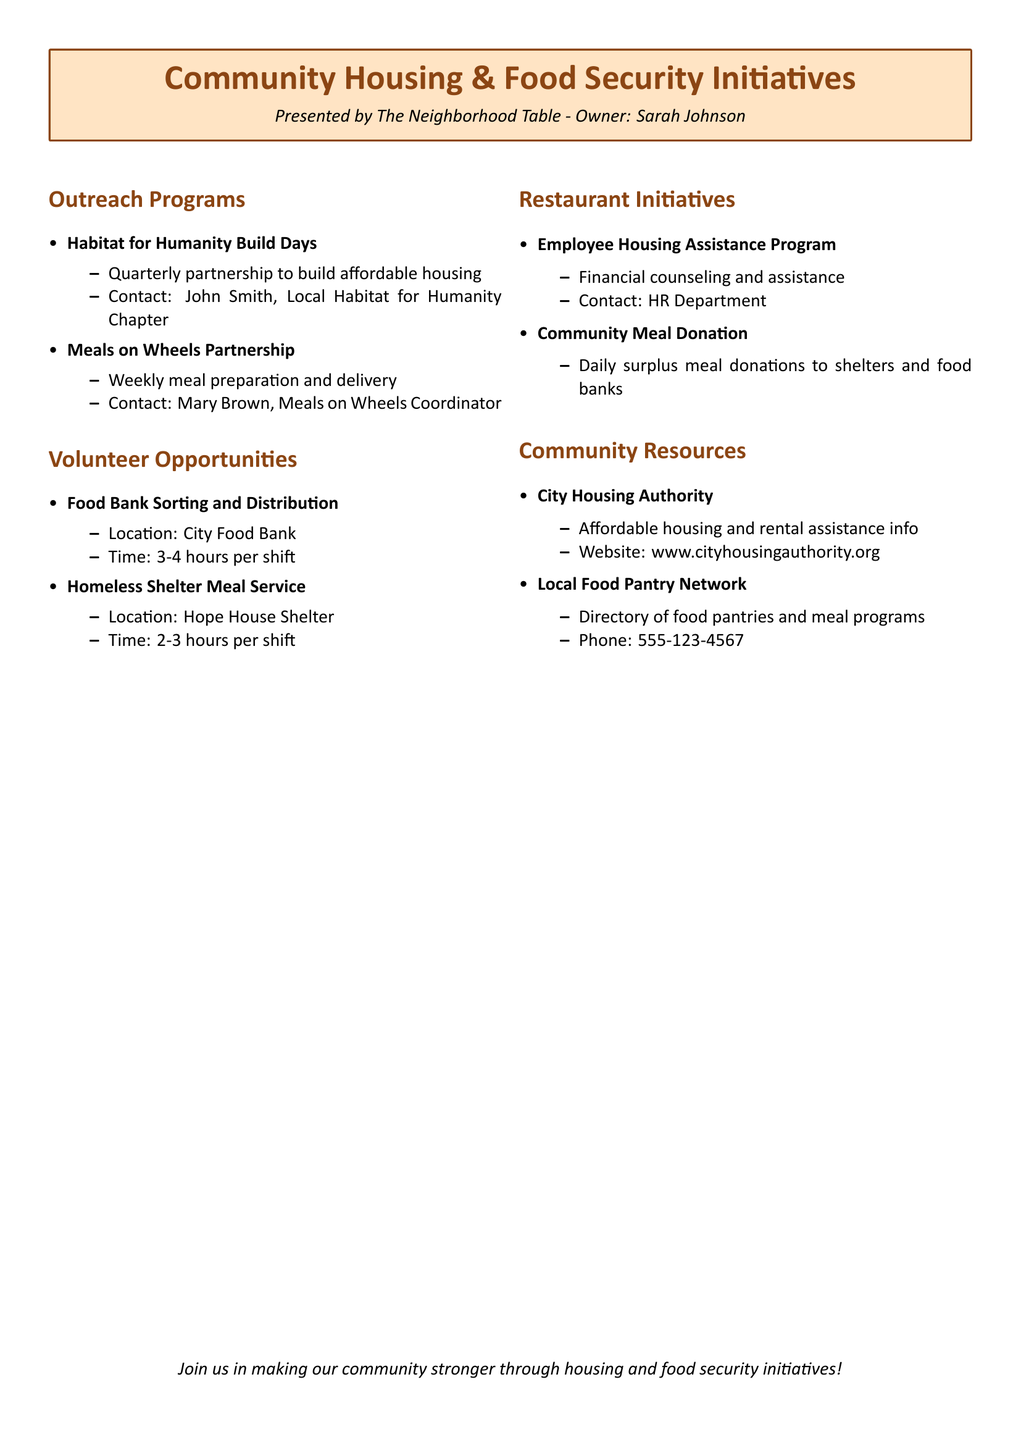What is the name of the restaurant owner? The document presents outreach programs and volunteer opportunities by The Neighborhood Table owned by Sarah Johnson.
Answer: Sarah Johnson How often do Habitat for Humanity Build Days occur? The document states that the partnership for these build days is quarterly.
Answer: Quarterly Who is the contact person for Meals on Wheels? The document provides the contact name for Meals on Wheels as Mary Brown who is the Coordinator.
Answer: Mary Brown What is the duration of a shift at the food bank? The document specifies that a shift at the City Food Bank lasts for 3-4 hours.
Answer: 3-4 hours What type of assistance does the Employee Housing Assistance Program offer? The document describes this program as providing financial counseling and assistance for employees.
Answer: Financial counseling and assistance What organization provides information on affordable housing? The document mentions the City Housing Authority as the resource for affordable housing and rental assistance information.
Answer: City Housing Authority Where is the Homeless Shelter Meal Service located? The document states that the Homeless Shelter Meal Service takes place at Hope House Shelter.
Answer: Hope House Shelter What initiative does the restaurant have for excess food? The document describes a Community Meal Donation initiative where daily surplus meals are donated to shelters and food banks.
Answer: Daily surplus meal donations What is the phone number for the Local Food Pantry Network? The document lists the contact number for the Local Food Pantry Network as 555-123-4567.
Answer: 555-123-4567 